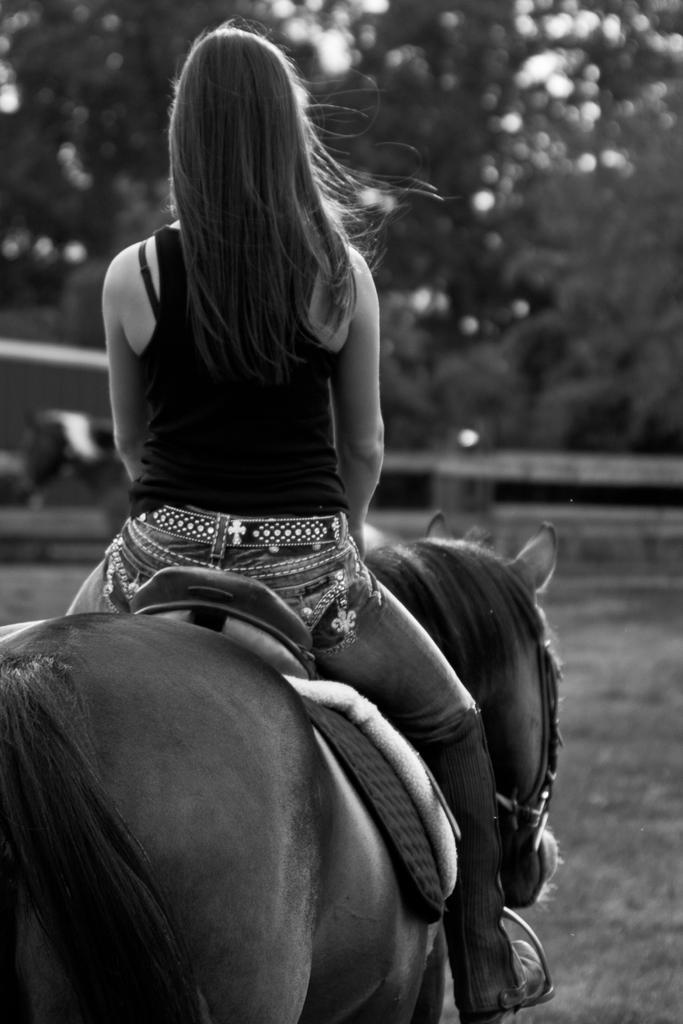How would you summarize this image in a sentence or two? This is a black and white image. Here is the woman sitting on the horse and riding. She wore T-shirt and trouser. At the background I can see trees. This looks like a grass. 